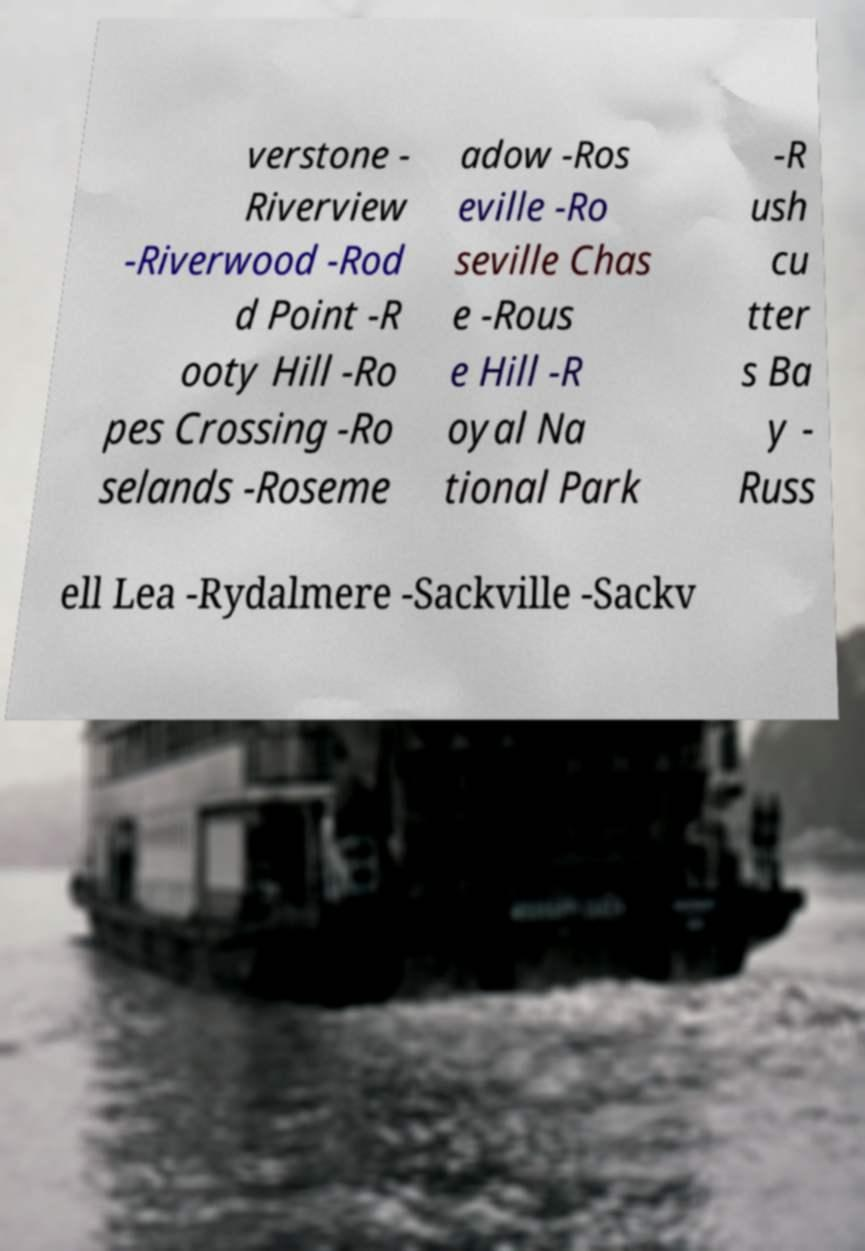Can you read and provide the text displayed in the image?This photo seems to have some interesting text. Can you extract and type it out for me? verstone - Riverview -Riverwood -Rod d Point -R ooty Hill -Ro pes Crossing -Ro selands -Roseme adow -Ros eville -Ro seville Chas e -Rous e Hill -R oyal Na tional Park -R ush cu tter s Ba y - Russ ell Lea -Rydalmere -Sackville -Sackv 